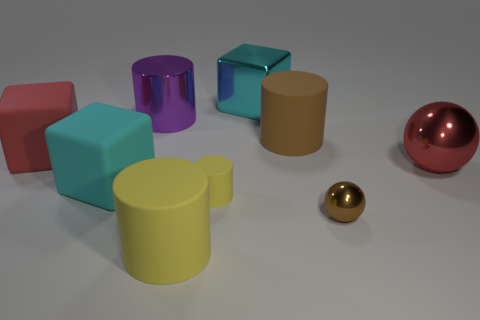How do the reflections and lighting in this image provide information about the surface they're on? The reflections on the objects, particularly the spheres and cylinders, show a smooth and shiny surface, indicating the objects are on a glossy and possibly reflective material. The soft shadows cast by the shapes suggest diffuse lighting in the scene, which gives the image a soft and realistic look. These visual cues imply the surface could be a form of polished stone or lacquered table. 